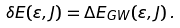<formula> <loc_0><loc_0><loc_500><loc_500>\delta E ( \varepsilon , J ) = \Delta E _ { G W } ( \varepsilon , J ) \, .</formula> 